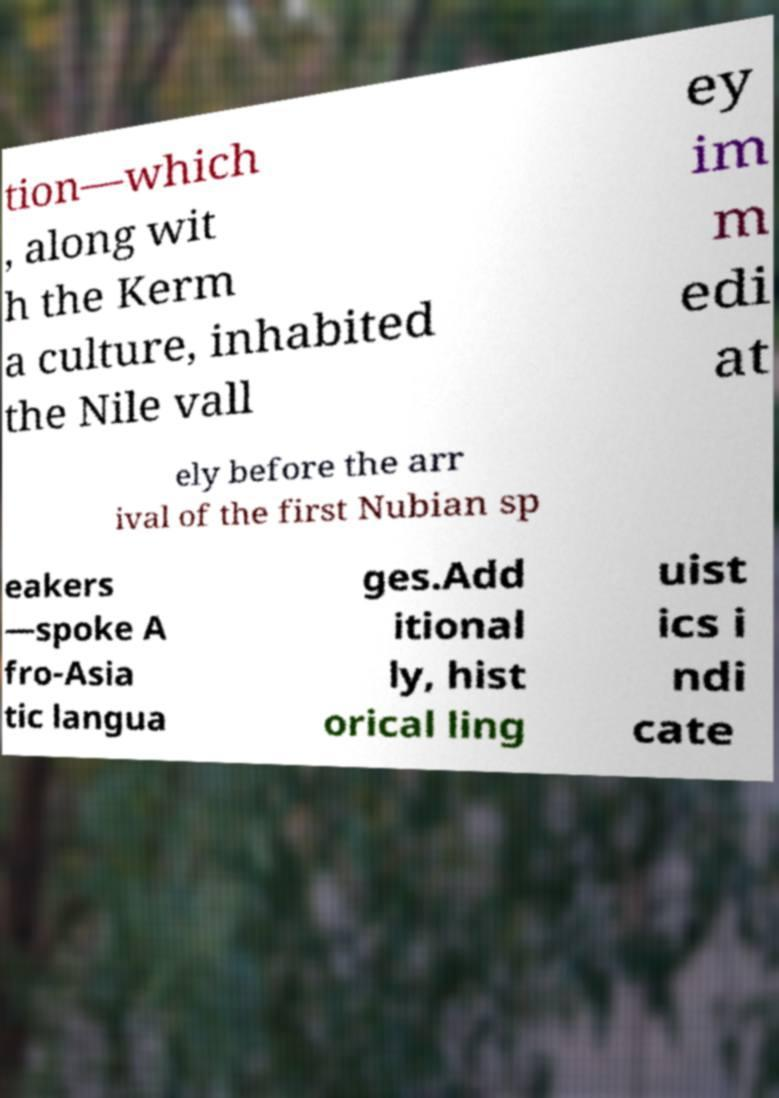What messages or text are displayed in this image? I need them in a readable, typed format. tion—which , along wit h the Kerm a culture, inhabited the Nile vall ey im m edi at ely before the arr ival of the first Nubian sp eakers —spoke A fro-Asia tic langua ges.Add itional ly, hist orical ling uist ics i ndi cate 